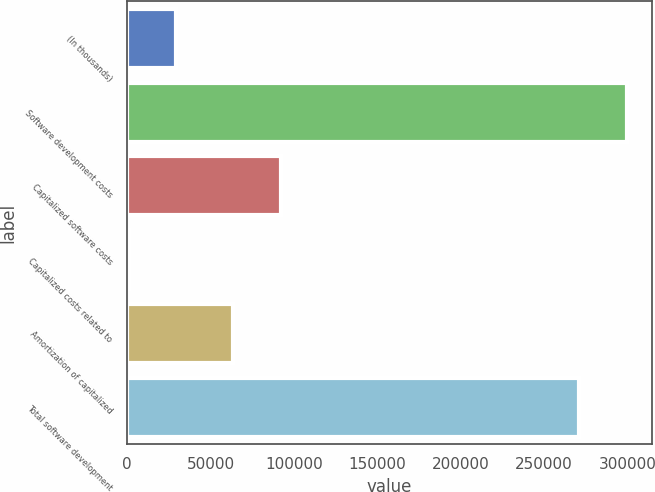Convert chart. <chart><loc_0><loc_0><loc_500><loc_500><bar_chart><fcel>(In thousands)<fcel>Software development costs<fcel>Capitalized software costs<fcel>Capitalized costs related to<fcel>Amortization of capitalized<fcel>Total software development<nl><fcel>29302.6<fcel>299483<fcel>92042.6<fcel>871<fcel>63611<fcel>271051<nl></chart> 